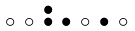<formula> <loc_0><loc_0><loc_500><loc_500>\begin{smallmatrix} & & \bullet \\ \circ & \circ & \bullet & \bullet & \circ & \bullet & \circ & \\ \end{smallmatrix}</formula> 